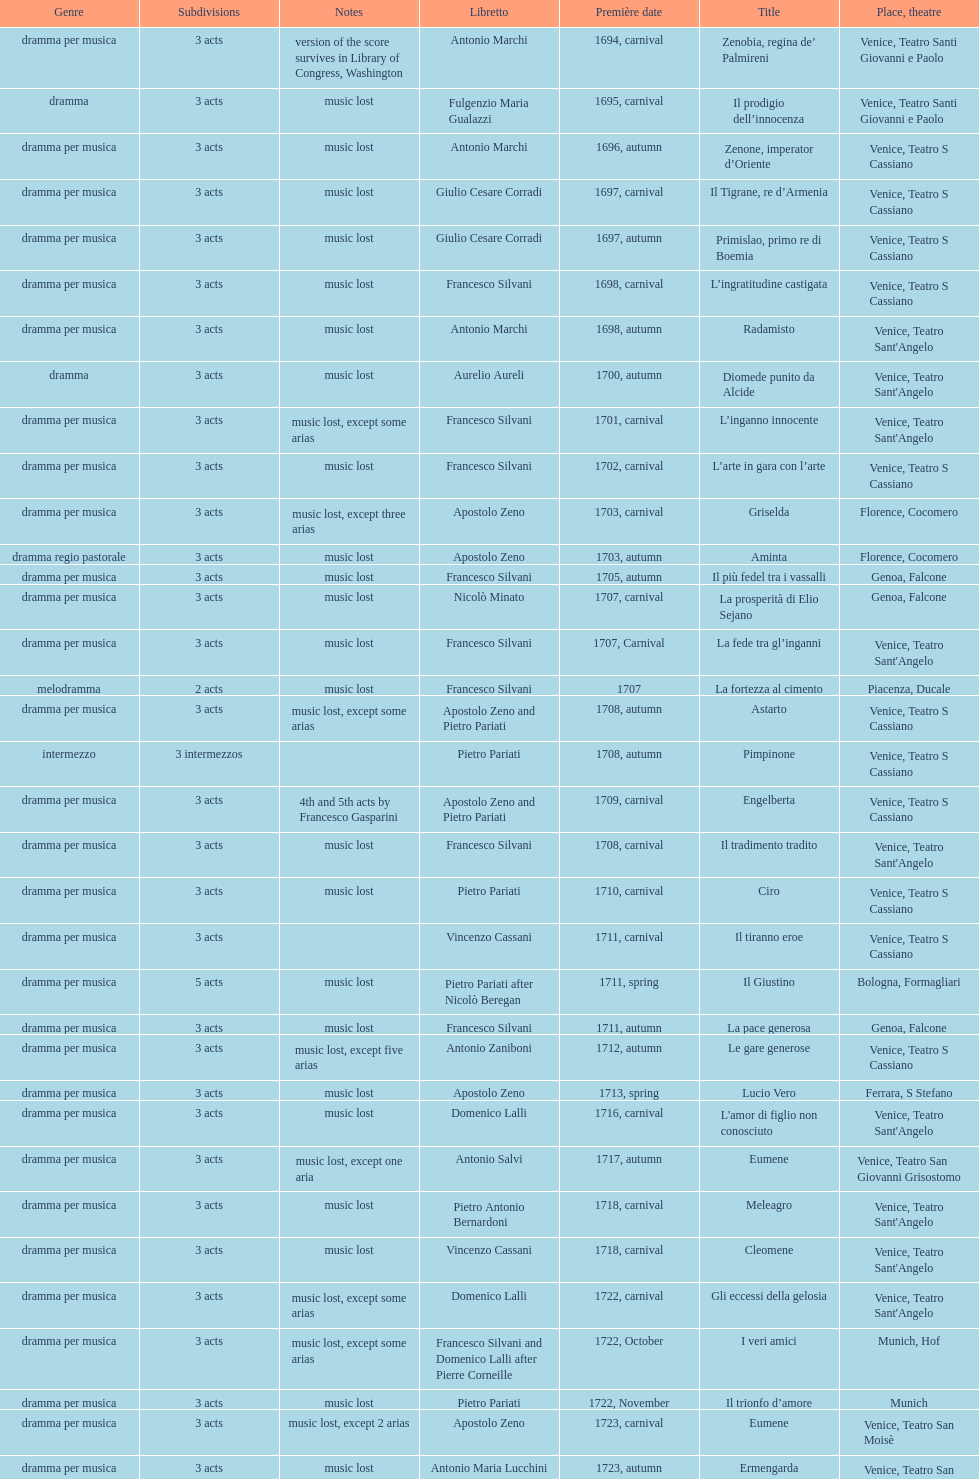L'inganno innocente premiered in 1701. what was the previous title released? Diomede punito da Alcide. 